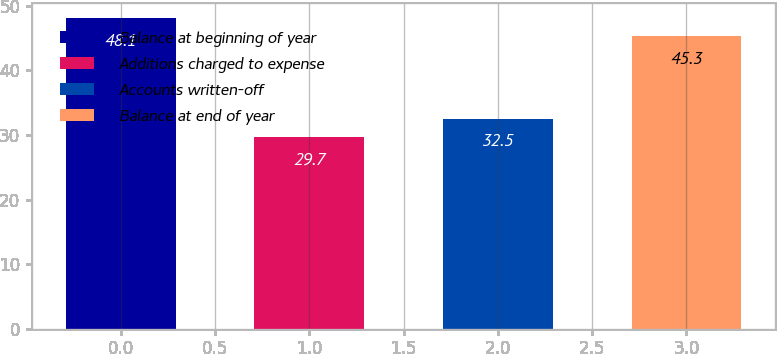Convert chart. <chart><loc_0><loc_0><loc_500><loc_500><bar_chart><fcel>Balance at beginning of year<fcel>Additions charged to expense<fcel>Accounts written-off<fcel>Balance at end of year<nl><fcel>48.1<fcel>29.7<fcel>32.5<fcel>45.3<nl></chart> 